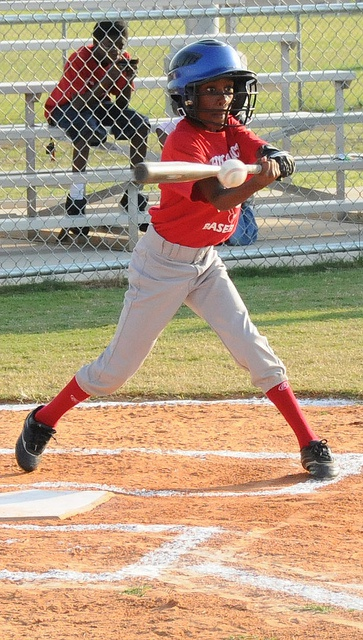Describe the objects in this image and their specific colors. I can see people in gray, darkgray, brown, black, and maroon tones, people in gray, black, darkgray, and maroon tones, bench in gray, darkgray, lightgray, and beige tones, baseball bat in gray, white, and tan tones, and bench in gray, darkgray, and lightgray tones in this image. 